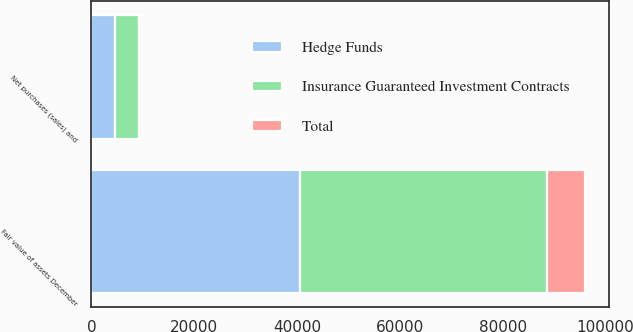Convert chart to OTSL. <chart><loc_0><loc_0><loc_500><loc_500><stacked_bar_chart><ecel><fcel>Fair value of assets December<fcel>Net purchases (sales) and<nl><fcel>Insurance Guaranteed Investment Contracts<fcel>47966<fcel>4832<nl><fcel>Total<fcel>7395<fcel>309<nl><fcel>Hedge Funds<fcel>40571<fcel>4523<nl></chart> 